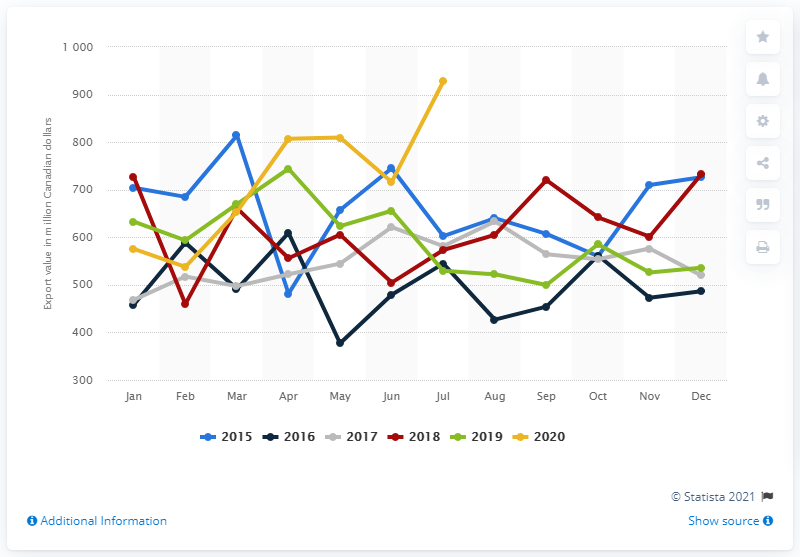Outline some significant characteristics in this image. In July 2020, the export value of wheat from Canada was approximately $927.5 million in U.S. dollars. 